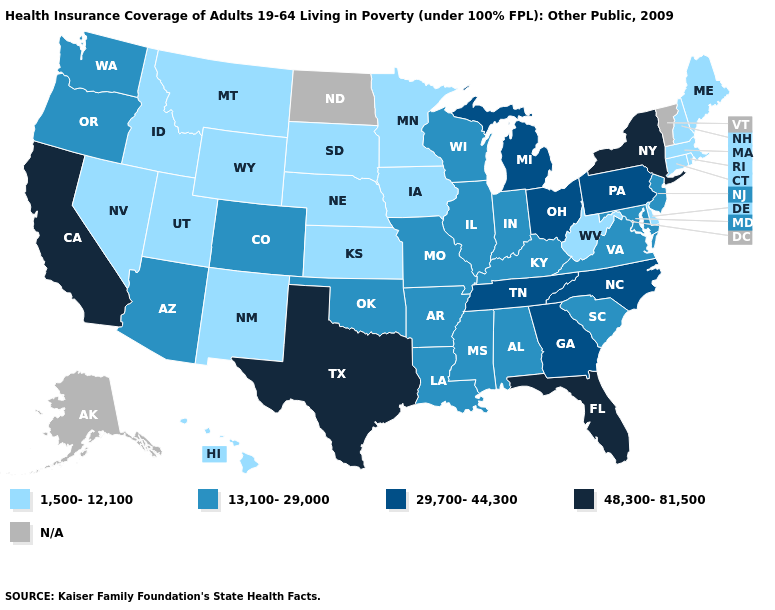Does Delaware have the lowest value in the USA?
Be succinct. Yes. What is the value of Arkansas?
Short answer required. 13,100-29,000. What is the value of North Carolina?
Short answer required. 29,700-44,300. Does Kansas have the lowest value in the MidWest?
Keep it brief. Yes. What is the lowest value in states that border Texas?
Give a very brief answer. 1,500-12,100. What is the highest value in the West ?
Write a very short answer. 48,300-81,500. What is the highest value in the Northeast ?
Give a very brief answer. 48,300-81,500. What is the value of Louisiana?
Keep it brief. 13,100-29,000. Name the states that have a value in the range 13,100-29,000?
Give a very brief answer. Alabama, Arizona, Arkansas, Colorado, Illinois, Indiana, Kentucky, Louisiana, Maryland, Mississippi, Missouri, New Jersey, Oklahoma, Oregon, South Carolina, Virginia, Washington, Wisconsin. Does West Virginia have the lowest value in the USA?
Give a very brief answer. Yes. How many symbols are there in the legend?
Quick response, please. 5. Which states have the lowest value in the Northeast?
Answer briefly. Connecticut, Maine, Massachusetts, New Hampshire, Rhode Island. 